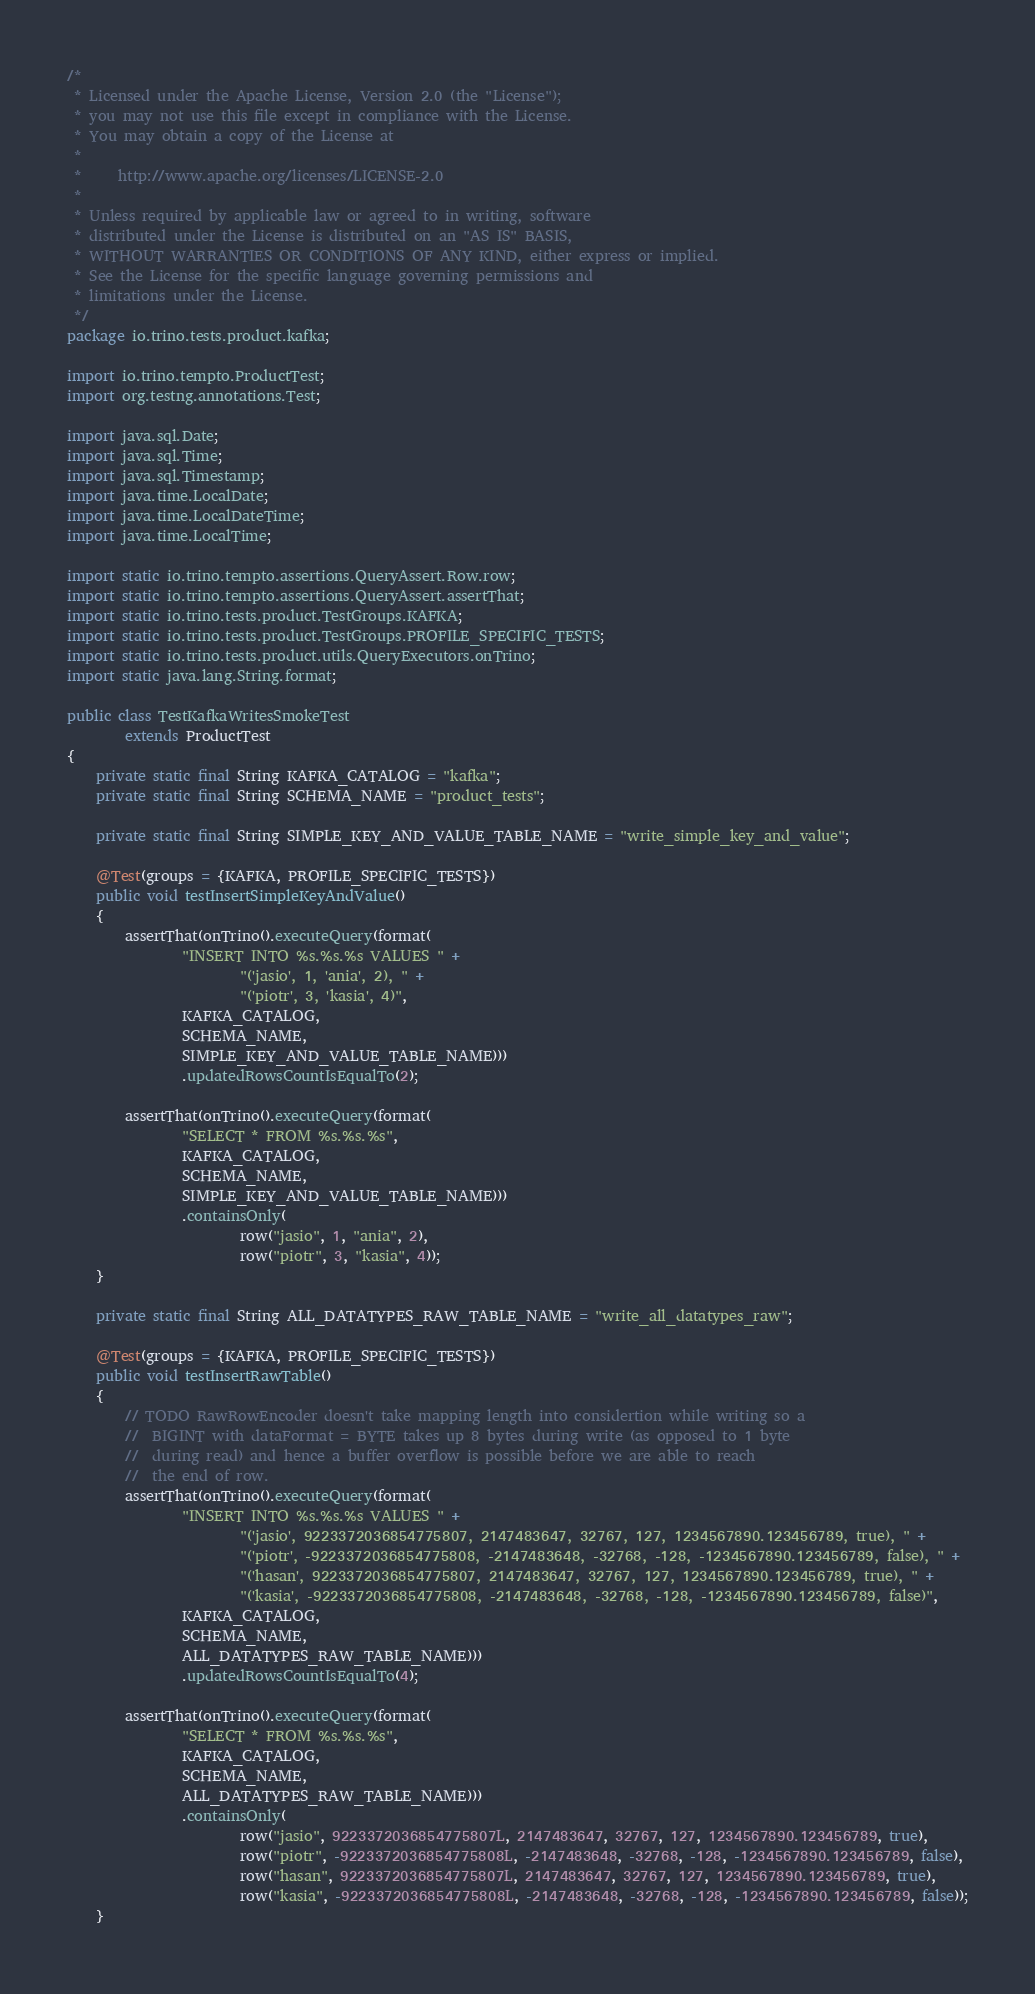<code> <loc_0><loc_0><loc_500><loc_500><_Java_>/*
 * Licensed under the Apache License, Version 2.0 (the "License");
 * you may not use this file except in compliance with the License.
 * You may obtain a copy of the License at
 *
 *     http://www.apache.org/licenses/LICENSE-2.0
 *
 * Unless required by applicable law or agreed to in writing, software
 * distributed under the License is distributed on an "AS IS" BASIS,
 * WITHOUT WARRANTIES OR CONDITIONS OF ANY KIND, either express or implied.
 * See the License for the specific language governing permissions and
 * limitations under the License.
 */
package io.trino.tests.product.kafka;

import io.trino.tempto.ProductTest;
import org.testng.annotations.Test;

import java.sql.Date;
import java.sql.Time;
import java.sql.Timestamp;
import java.time.LocalDate;
import java.time.LocalDateTime;
import java.time.LocalTime;

import static io.trino.tempto.assertions.QueryAssert.Row.row;
import static io.trino.tempto.assertions.QueryAssert.assertThat;
import static io.trino.tests.product.TestGroups.KAFKA;
import static io.trino.tests.product.TestGroups.PROFILE_SPECIFIC_TESTS;
import static io.trino.tests.product.utils.QueryExecutors.onTrino;
import static java.lang.String.format;

public class TestKafkaWritesSmokeTest
        extends ProductTest
{
    private static final String KAFKA_CATALOG = "kafka";
    private static final String SCHEMA_NAME = "product_tests";

    private static final String SIMPLE_KEY_AND_VALUE_TABLE_NAME = "write_simple_key_and_value";

    @Test(groups = {KAFKA, PROFILE_SPECIFIC_TESTS})
    public void testInsertSimpleKeyAndValue()
    {
        assertThat(onTrino().executeQuery(format(
                "INSERT INTO %s.%s.%s VALUES " +
                        "('jasio', 1, 'ania', 2), " +
                        "('piotr', 3, 'kasia', 4)",
                KAFKA_CATALOG,
                SCHEMA_NAME,
                SIMPLE_KEY_AND_VALUE_TABLE_NAME)))
                .updatedRowsCountIsEqualTo(2);

        assertThat(onTrino().executeQuery(format(
                "SELECT * FROM %s.%s.%s",
                KAFKA_CATALOG,
                SCHEMA_NAME,
                SIMPLE_KEY_AND_VALUE_TABLE_NAME)))
                .containsOnly(
                        row("jasio", 1, "ania", 2),
                        row("piotr", 3, "kasia", 4));
    }

    private static final String ALL_DATATYPES_RAW_TABLE_NAME = "write_all_datatypes_raw";

    @Test(groups = {KAFKA, PROFILE_SPECIFIC_TESTS})
    public void testInsertRawTable()
    {
        // TODO RawRowEncoder doesn't take mapping length into considertion while writing so a
        //  BIGINT with dataFormat = BYTE takes up 8 bytes during write (as opposed to 1 byte
        //  during read) and hence a buffer overflow is possible before we are able to reach
        //  the end of row.
        assertThat(onTrino().executeQuery(format(
                "INSERT INTO %s.%s.%s VALUES " +
                        "('jasio', 9223372036854775807, 2147483647, 32767, 127, 1234567890.123456789, true), " +
                        "('piotr', -9223372036854775808, -2147483648, -32768, -128, -1234567890.123456789, false), " +
                        "('hasan', 9223372036854775807, 2147483647, 32767, 127, 1234567890.123456789, true), " +
                        "('kasia', -9223372036854775808, -2147483648, -32768, -128, -1234567890.123456789, false)",
                KAFKA_CATALOG,
                SCHEMA_NAME,
                ALL_DATATYPES_RAW_TABLE_NAME)))
                .updatedRowsCountIsEqualTo(4);

        assertThat(onTrino().executeQuery(format(
                "SELECT * FROM %s.%s.%s",
                KAFKA_CATALOG,
                SCHEMA_NAME,
                ALL_DATATYPES_RAW_TABLE_NAME)))
                .containsOnly(
                        row("jasio", 9223372036854775807L, 2147483647, 32767, 127, 1234567890.123456789, true),
                        row("piotr", -9223372036854775808L, -2147483648, -32768, -128, -1234567890.123456789, false),
                        row("hasan", 9223372036854775807L, 2147483647, 32767, 127, 1234567890.123456789, true),
                        row("kasia", -9223372036854775808L, -2147483648, -32768, -128, -1234567890.123456789, false));
    }
</code> 